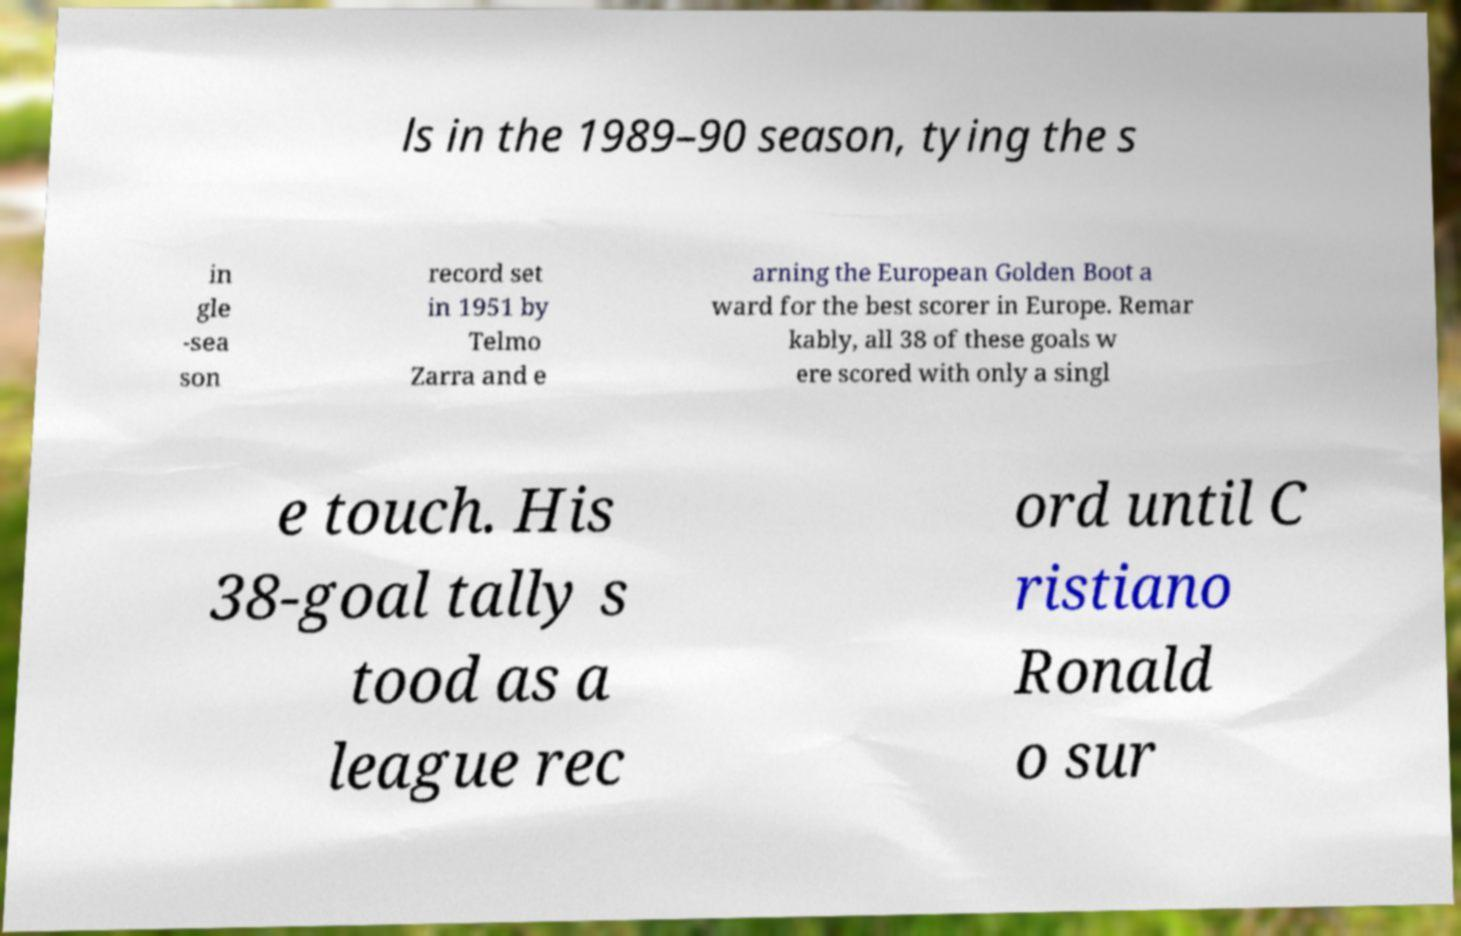Please read and relay the text visible in this image. What does it say? ls in the 1989–90 season, tying the s in gle -sea son record set in 1951 by Telmo Zarra and e arning the European Golden Boot a ward for the best scorer in Europe. Remar kably, all 38 of these goals w ere scored with only a singl e touch. His 38-goal tally s tood as a league rec ord until C ristiano Ronald o sur 